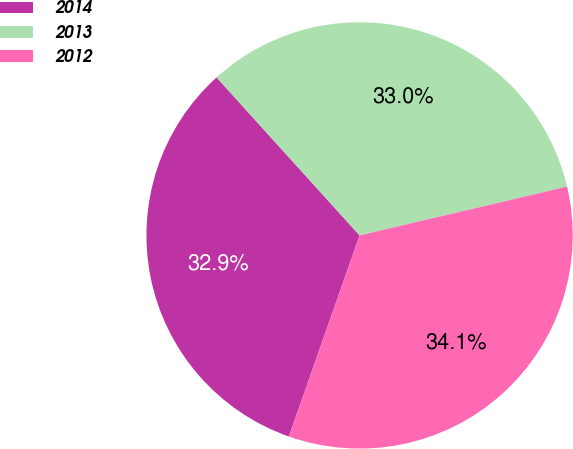<chart> <loc_0><loc_0><loc_500><loc_500><pie_chart><fcel>2014<fcel>2013<fcel>2012<nl><fcel>32.91%<fcel>33.03%<fcel>34.06%<nl></chart> 